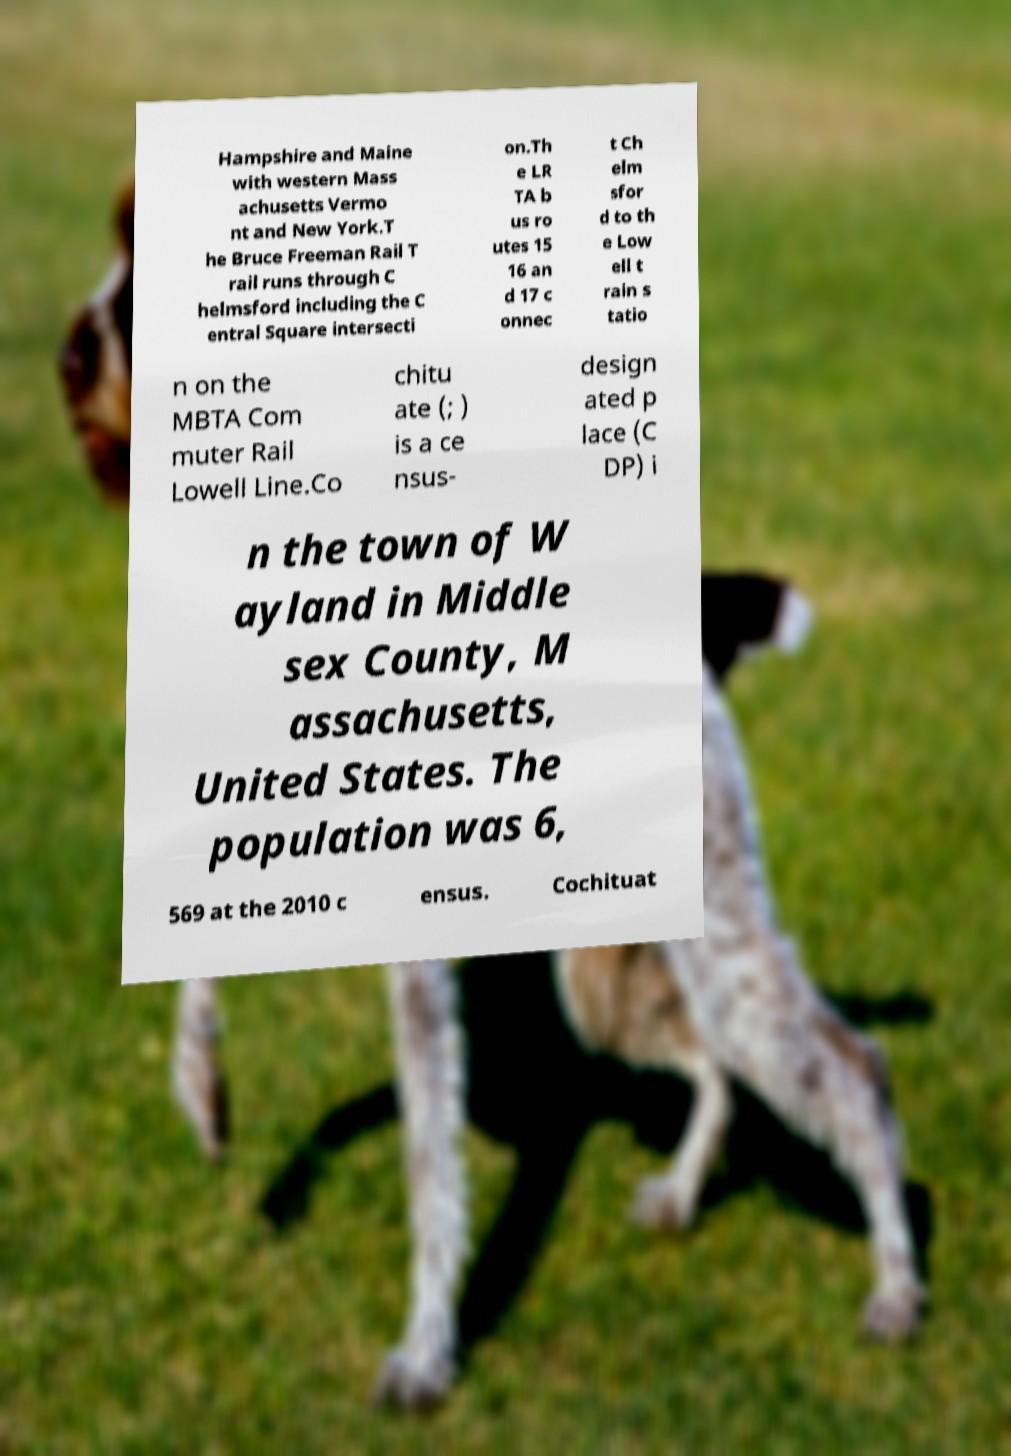Please read and relay the text visible in this image. What does it say? Hampshire and Maine with western Mass achusetts Vermo nt and New York.T he Bruce Freeman Rail T rail runs through C helmsford including the C entral Square intersecti on.Th e LR TA b us ro utes 15 16 an d 17 c onnec t Ch elm sfor d to th e Low ell t rain s tatio n on the MBTA Com muter Rail Lowell Line.Co chitu ate (; ) is a ce nsus- design ated p lace (C DP) i n the town of W ayland in Middle sex County, M assachusetts, United States. The population was 6, 569 at the 2010 c ensus. Cochituat 